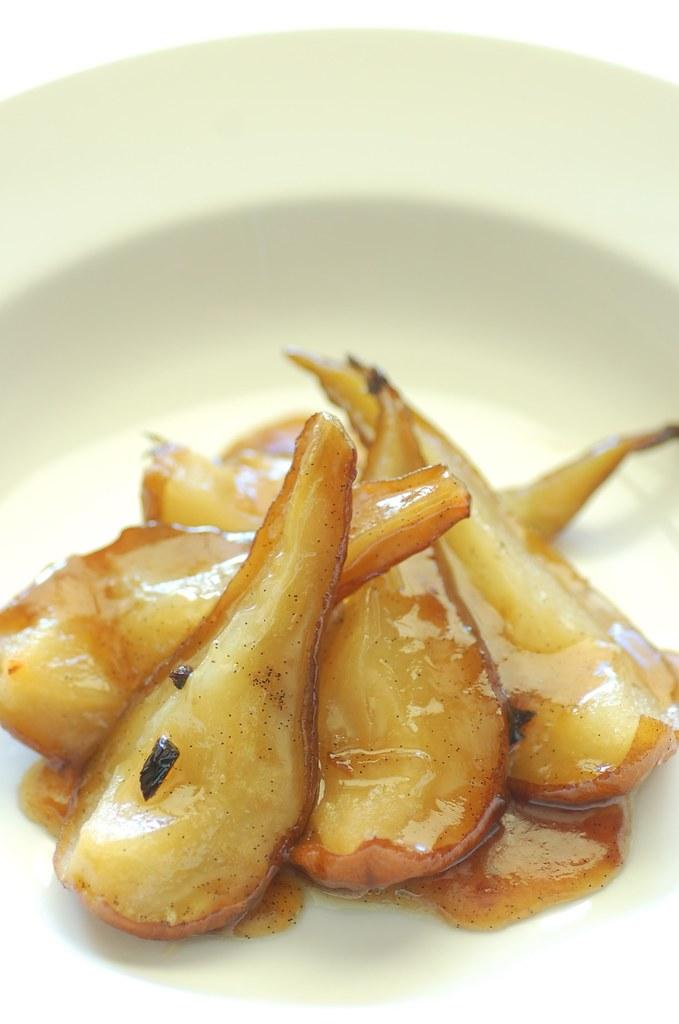What color is the bowl in the image? The bowl in the image is white. What is inside the bowl? The bowl contains a food item. How many cherries are floating in the liquid inside the bowl? There is no liquid or cherries present in the image; the bowl contains a food item. 